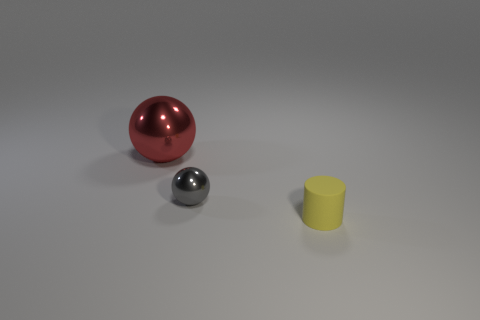Subtract all spheres. How many objects are left? 1 Subtract all cyan cylinders. Subtract all brown blocks. How many cylinders are left? 1 Add 3 large blue balls. How many large blue balls exist? 3 Add 2 red shiny spheres. How many objects exist? 5 Subtract 0 cyan blocks. How many objects are left? 3 Subtract 1 cylinders. How many cylinders are left? 0 Subtract all cyan balls. How many purple cylinders are left? 0 Subtract all big cyan things. Subtract all tiny yellow things. How many objects are left? 2 Add 3 big spheres. How many big spheres are left? 4 